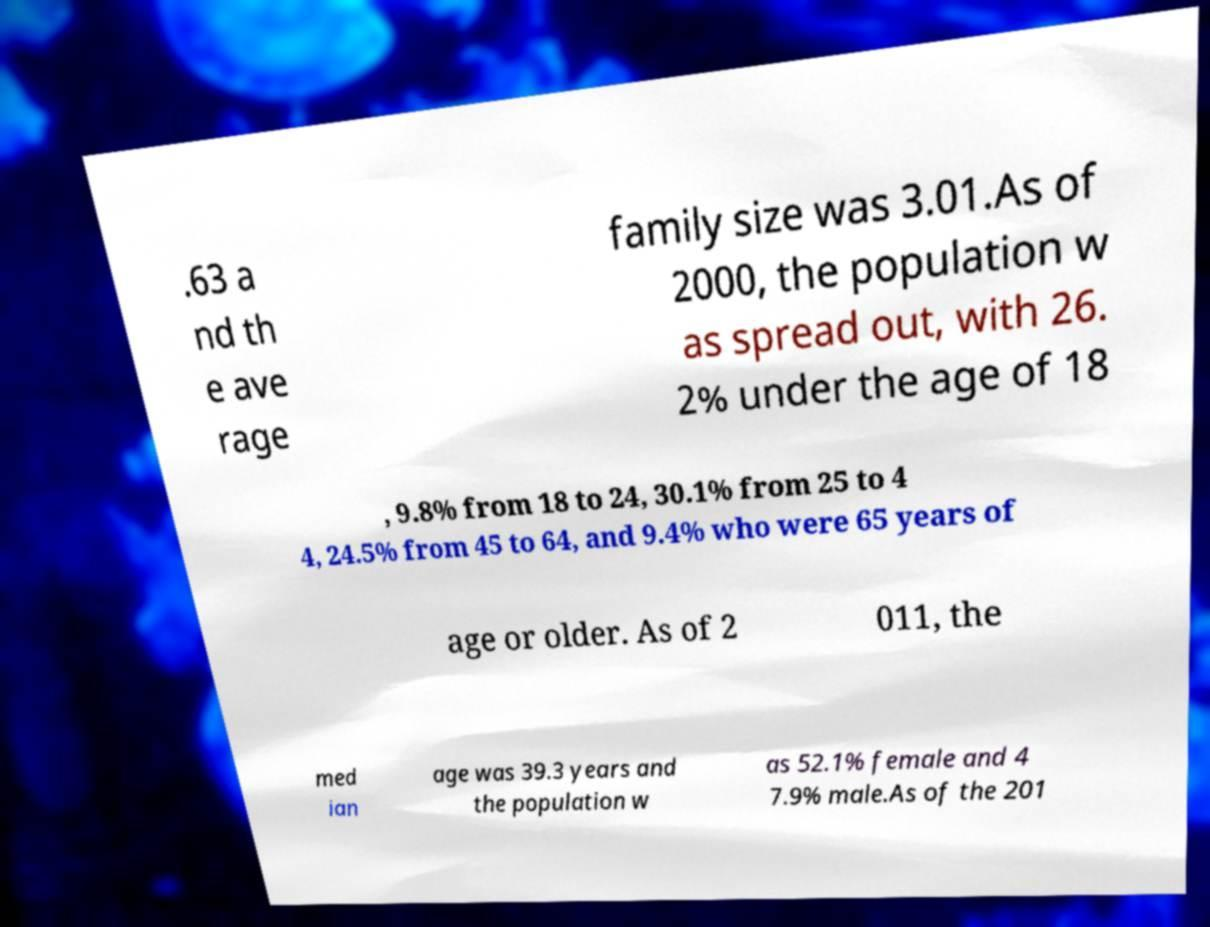For documentation purposes, I need the text within this image transcribed. Could you provide that? .63 a nd th e ave rage family size was 3.01.As of 2000, the population w as spread out, with 26. 2% under the age of 18 , 9.8% from 18 to 24, 30.1% from 25 to 4 4, 24.5% from 45 to 64, and 9.4% who were 65 years of age or older. As of 2 011, the med ian age was 39.3 years and the population w as 52.1% female and 4 7.9% male.As of the 201 